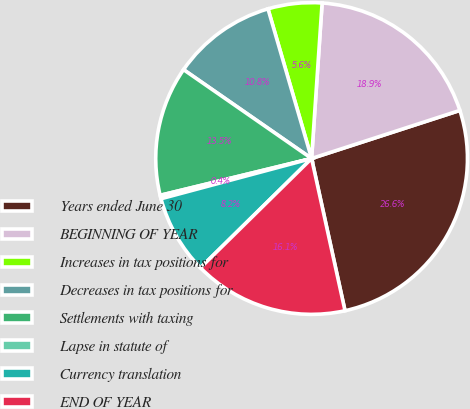<chart> <loc_0><loc_0><loc_500><loc_500><pie_chart><fcel>Years ended June 30<fcel>BEGINNING OF YEAR<fcel>Increases in tax positions for<fcel>Decreases in tax positions for<fcel>Settlements with taxing<fcel>Lapse in statute of<fcel>Currency translation<fcel>END OF YEAR<nl><fcel>26.55%<fcel>18.93%<fcel>5.59%<fcel>10.83%<fcel>13.45%<fcel>0.36%<fcel>8.21%<fcel>16.07%<nl></chart> 